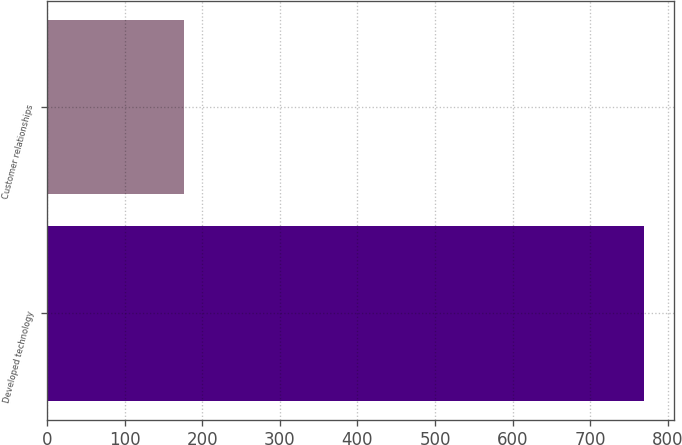Convert chart. <chart><loc_0><loc_0><loc_500><loc_500><bar_chart><fcel>Developed technology<fcel>Customer relationships<nl><fcel>769<fcel>177<nl></chart> 